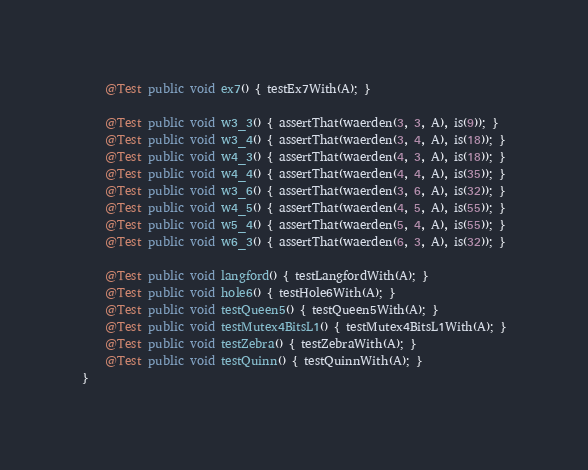Convert code to text. <code><loc_0><loc_0><loc_500><loc_500><_Java_>    @Test public void ex7() { testEx7With(A); }

    @Test public void w3_3() { assertThat(waerden(3, 3, A), is(9)); }
    @Test public void w3_4() { assertThat(waerden(3, 4, A), is(18)); }
    @Test public void w4_3() { assertThat(waerden(4, 3, A), is(18)); }
    @Test public void w4_4() { assertThat(waerden(4, 4, A), is(35)); }
    @Test public void w3_6() { assertThat(waerden(3, 6, A), is(32)); }
    @Test public void w4_5() { assertThat(waerden(4, 5, A), is(55)); }
    @Test public void w5_4() { assertThat(waerden(5, 4, A), is(55)); }
    @Test public void w6_3() { assertThat(waerden(6, 3, A), is(32)); }

    @Test public void langford() { testLangfordWith(A); }
    @Test public void hole6() { testHole6With(A); }
    @Test public void testQueen5() { testQueen5With(A); }
    @Test public void testMutex4BitsL1() { testMutex4BitsL1With(A); }
    @Test public void testZebra() { testZebraWith(A); }
    @Test public void testQuinn() { testQuinnWith(A); }
}
</code> 